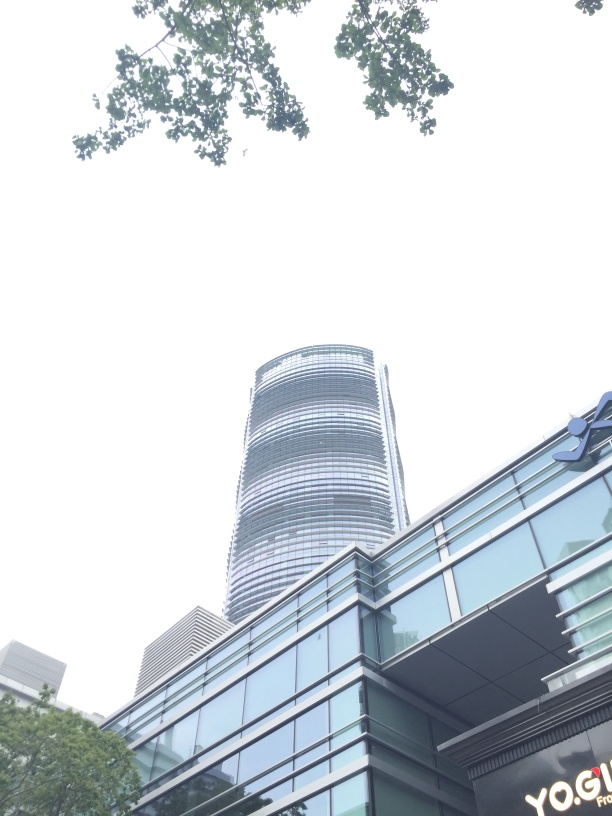What kind of businesses might be inside this modern skyscraper? Modern skyscrapers like this often house a variety of businesses, including corporate offices, legal firms, tech startups, and possibly luxury apartments or a boutique hotel. The lower floors may contain retail spaces or restaurants. 